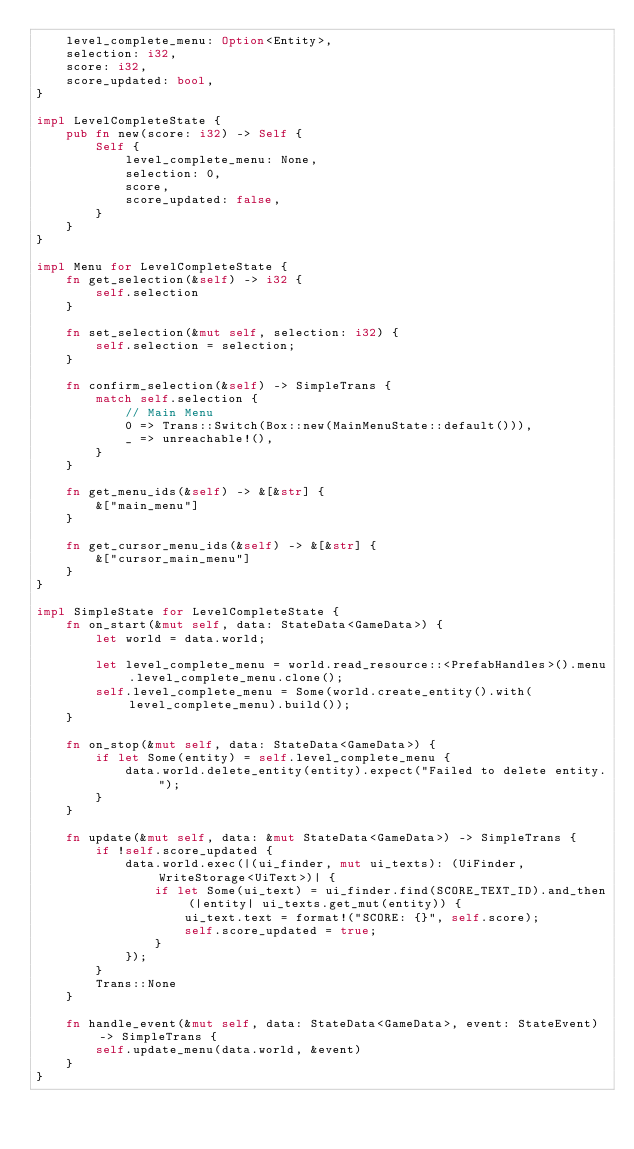Convert code to text. <code><loc_0><loc_0><loc_500><loc_500><_Rust_>    level_complete_menu: Option<Entity>,
    selection: i32,
    score: i32,
    score_updated: bool,
}

impl LevelCompleteState {
    pub fn new(score: i32) -> Self {
        Self {
            level_complete_menu: None,
            selection: 0,
            score,
            score_updated: false,
        }
    }
}

impl Menu for LevelCompleteState {
    fn get_selection(&self) -> i32 {
        self.selection
    }

    fn set_selection(&mut self, selection: i32) {
        self.selection = selection;
    }

    fn confirm_selection(&self) -> SimpleTrans {
        match self.selection {
            // Main Menu
            0 => Trans::Switch(Box::new(MainMenuState::default())),
            _ => unreachable!(),
        }
    }

    fn get_menu_ids(&self) -> &[&str] {
        &["main_menu"]
    }

    fn get_cursor_menu_ids(&self) -> &[&str] {
        &["cursor_main_menu"]
    }
}

impl SimpleState for LevelCompleteState {
    fn on_start(&mut self, data: StateData<GameData>) {
        let world = data.world;

        let level_complete_menu = world.read_resource::<PrefabHandles>().menu.level_complete_menu.clone();
        self.level_complete_menu = Some(world.create_entity().with(level_complete_menu).build());
    }

    fn on_stop(&mut self, data: StateData<GameData>) {
        if let Some(entity) = self.level_complete_menu {
            data.world.delete_entity(entity).expect("Failed to delete entity.");
        }
    }

    fn update(&mut self, data: &mut StateData<GameData>) -> SimpleTrans {
        if !self.score_updated {
            data.world.exec(|(ui_finder, mut ui_texts): (UiFinder, WriteStorage<UiText>)| {
                if let Some(ui_text) = ui_finder.find(SCORE_TEXT_ID).and_then(|entity| ui_texts.get_mut(entity)) {
                    ui_text.text = format!("SCORE: {}", self.score);
                    self.score_updated = true;
                }
            });
        }
        Trans::None
    }

    fn handle_event(&mut self, data: StateData<GameData>, event: StateEvent) -> SimpleTrans {
        self.update_menu(data.world, &event)
    }
}
</code> 